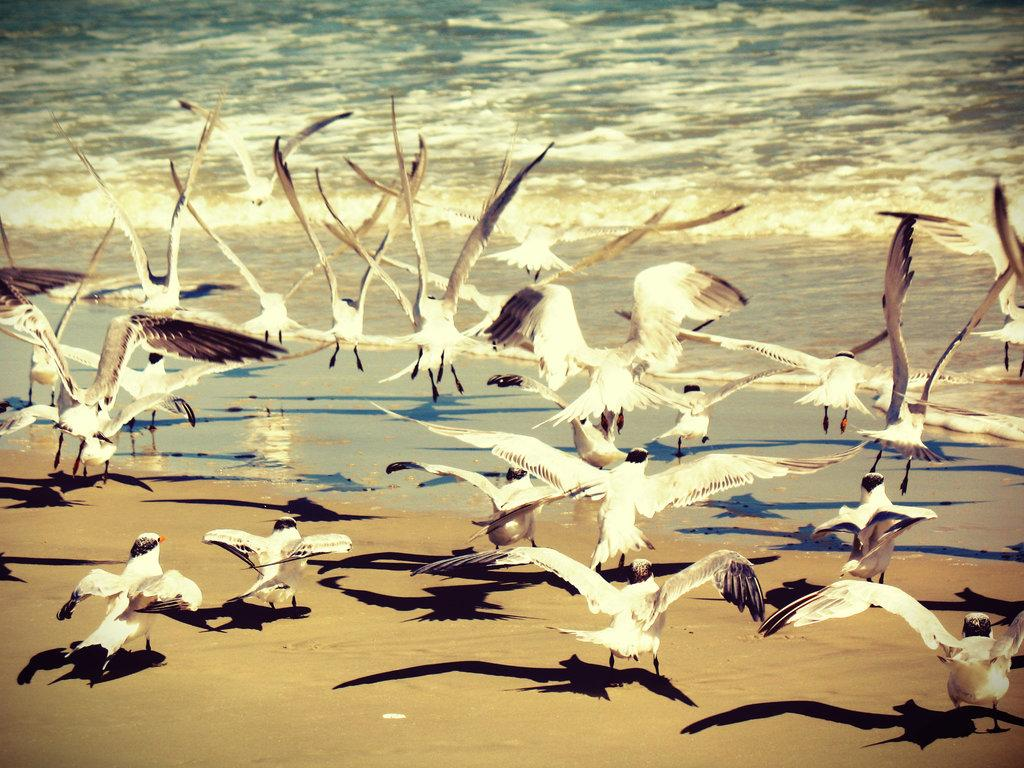What type of animals can be seen in the image? There are white color birds in the image. What are the birds doing in the image? The birds are flying in the air. What can be seen in the background of the image? There is water visible in the background of the image. What type of pleasure can be seen on the beetle's face in the image? There is no beetle present in the image, and therefore no facial expression to analyze. 